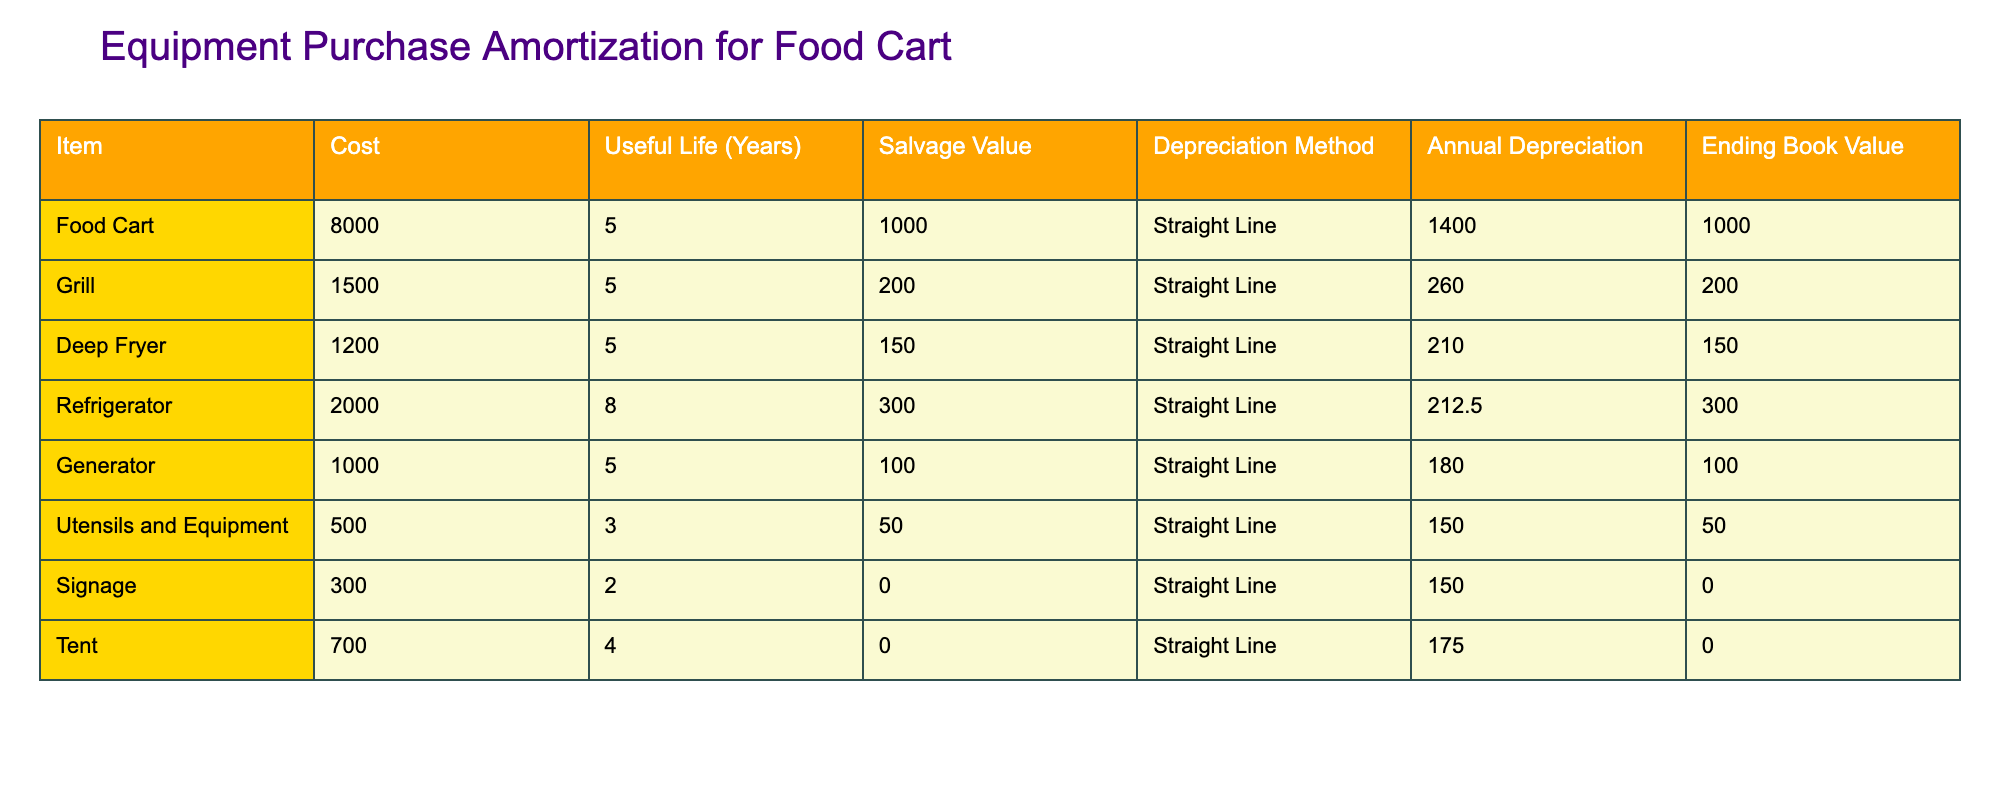What is the cost of the food cart? The table indicates the cost of the food cart in the "Cost" column. Referring to this column, the listed cost for the food cart is 8000.
Answer: 8000 What is the annual depreciation for the grill? To find the annual depreciation for the grill, we use the formula: (Cost - Salvage Value) / Useful Life. Here, it is (1500 - 200) / 5 = 260.
Answer: 260 Is the salvage value of the refrigerator greater than that of the deep fryer? The salvage value for the refrigerator is 300, while for the deep fryer it is 150. Since 300 is greater than 150, the statement is true.
Answer: Yes What is the total useful life of all the equipment combined? We sum the useful life of each equipment: 5 + 5 + 5 + 8 + 5 + 3 + 2 + 4 = 37. Therefore, the total useful life is 37 years.
Answer: 37 What is the ending book value of the generator after 5 years? The ending book value is calculated by taking the cost and subtracting the total depreciation. The depreciation for the generator is (1000 - 100) / 5 = 180. After 5 years, its book value is 1000 - (180 * 5) = 1000 - 900 = 100.
Answer: 100 Is the annual depreciation of utensils and equipment higher than that of signage? The annual depreciation for utensils and equipment is (500 - 50) / 3 = 150 and for signage it is (300 - 0) / 2 = 150. Since both values are equal, the answer is false.
Answer: No What equipment has the highest annual depreciation? By comparing the annual depreciation values calculated for each equipment, the fridge has the highest at 212.5 (calculated as (2000 - 300) / 8 = 212.5).
Answer: Refrigerator What is the average annual depreciation across all equipment? To find the average, we first sum the annual depreciation values and then divide by the number of items. The values are 1400, 260, 210, 212.5, 180, 150, 150, 175, which total 2825. There are 8 items, so 2825 / 8 = 353.125.
Answer: 353.13 What is the total cost of all equipment? We can find this by adding the costs of each piece of equipment: 8000 + 1500 + 1200 + 2000 + 1000 + 500 + 300 + 700 = 12000.
Answer: 12000 